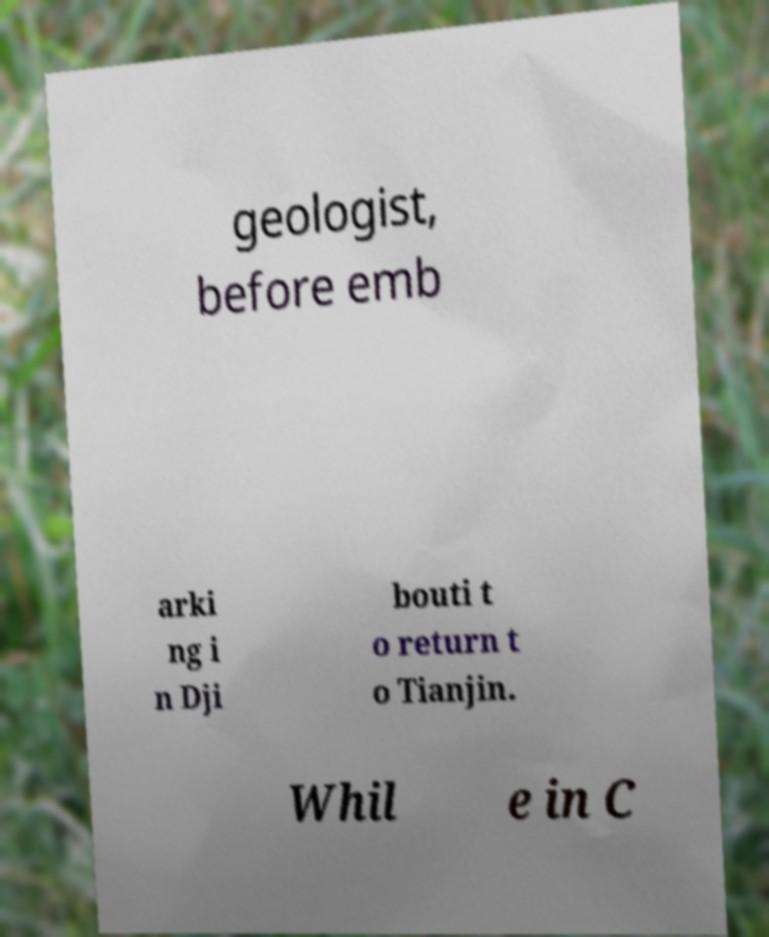I need the written content from this picture converted into text. Can you do that? geologist, before emb arki ng i n Dji bouti t o return t o Tianjin. Whil e in C 